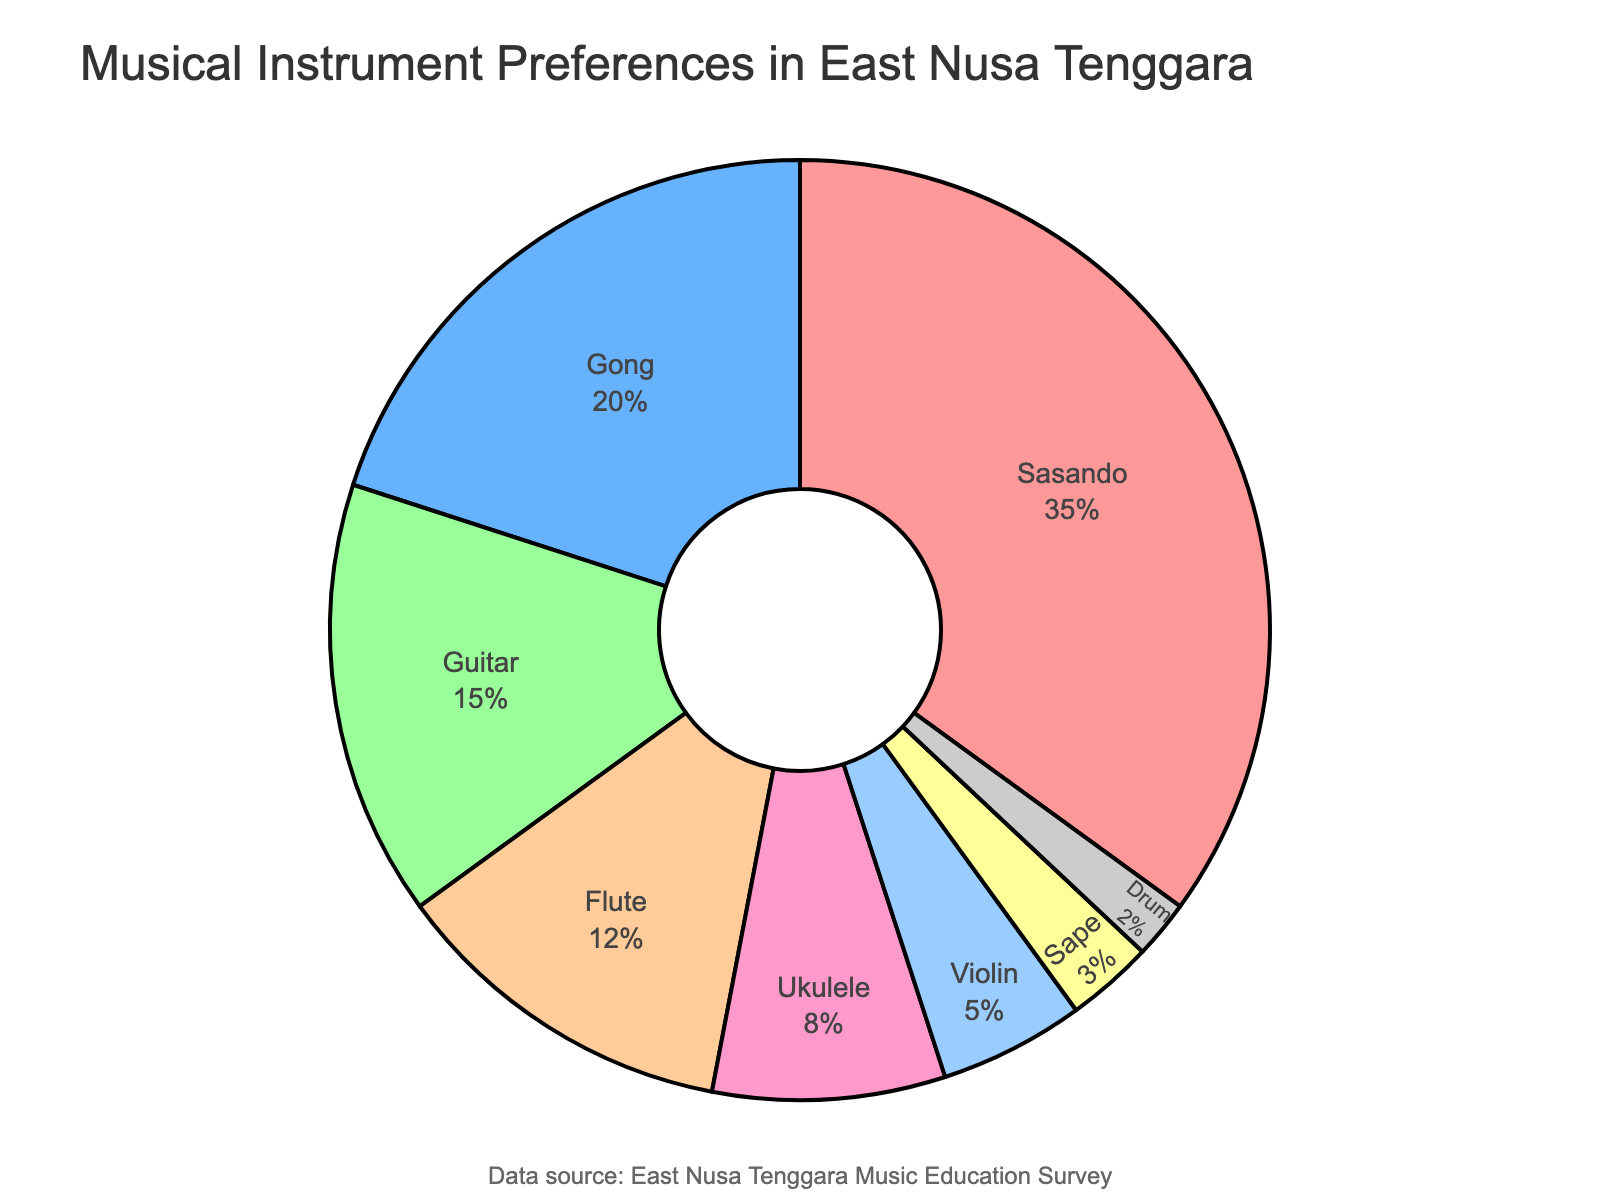What is the most preferred musical instrument among students? The pie chart shows the distribution of musical instrument preferences, with the Sasando segment being the largest.
Answer: Sasando Which instrument has the lowest preference among students? By looking at the smallest segment in the pie chart, which represents 2% of the student population.
Answer: Drum How much more popular is the Sasando compared to the Guitar? Sasando has a 35% preference, and Guitar has a 15% preference. The difference is 35% - 15% = 20%.
Answer: 20% What is the combined preference percentage for traditional instruments (Sasando, Gong, and Sape)? Sum the preference percentages for Sasando (35%), Gong (20%), and Sape (3%): 35% + 20% + 3% = 58%.
Answer: 58% Compare the preferences for Ukulele and Flute. Which one do students prefer more and by how much? The Flute has a 12% preference, and the Ukulele has an 8% preference. The difference is 12% - 8% = 4%.
Answer: Flute, by 4% What is the total percentage of students who prefer string instruments (Sasando, Guitar, Ukulele, Violin, and Sape)? Add the preference percentages for Sasando (35%), Guitar (15%), Ukulele (8%), Violin (5%), and Sape (3%): 35% + 15% + 8% + 5% + 3% = 66%.
Answer: 66% If you combine the preferences for Gong and Drum, how does their percentage compare to that of Guitar? Combine the percentages of Gong (20%) and Drum (2%): 20% + 2% = 22%. Compare to Guitar's 15% preference: 22% is greater than 15%.
Answer: 22% is greater than 15% What percentage of students prefer instruments that have a preference of 10% or more? Identify the instruments: Sasando (35%), Gong (20%), Guitar (15%), and Flute (12%). Sum their percentages: 35% + 20% + 15% + 12% = 82%.
Answer: 82% Which is preferred more: the Violin or the Drum? By what percentage difference? The Violin has a 5% preference and the Drum has a 2% preference. The difference is 5% - 2% = 3%.
Answer: Violin, by 3% If students were evenly split between Gong and Guitar, what percentage would each have? Currently, Gong has 20% and Guitar has 15%. Sum these and divide by 2: (20% + 15%) / 2 = 17.5%.
Answer: 17.5% 